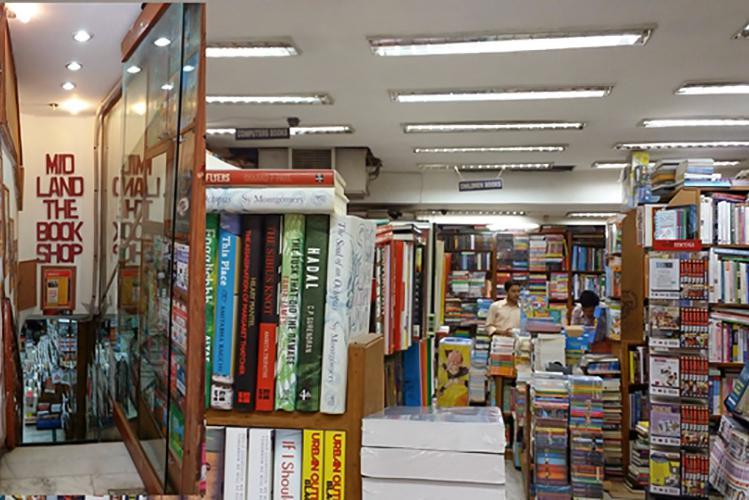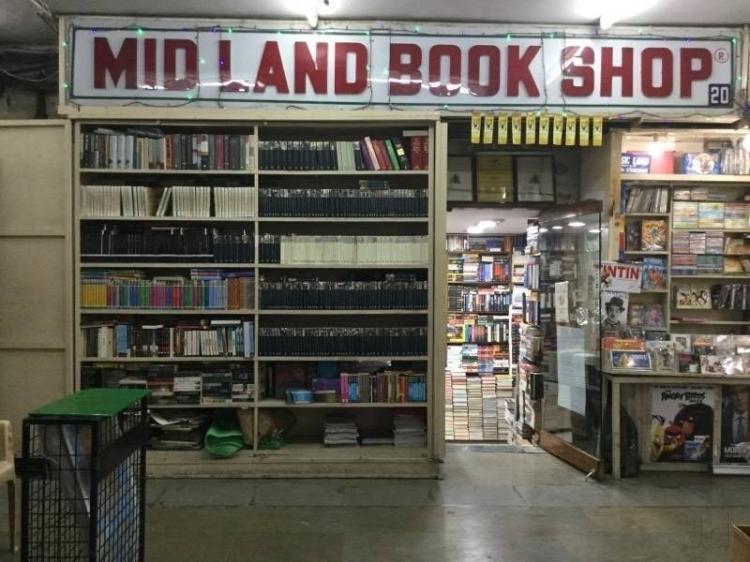The first image is the image on the left, the second image is the image on the right. For the images shown, is this caption "Each of the images features the outside of a store." true? Answer yes or no. No. 